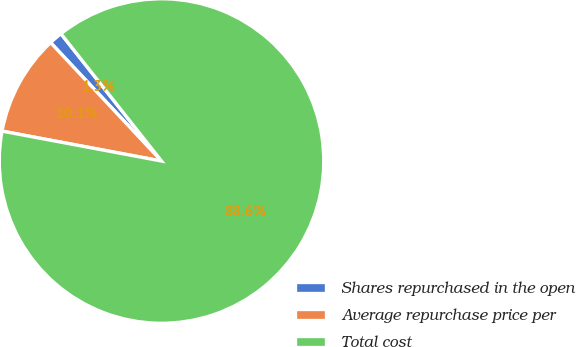Convert chart to OTSL. <chart><loc_0><loc_0><loc_500><loc_500><pie_chart><fcel>Shares repurchased in the open<fcel>Average repurchase price per<fcel>Total cost<nl><fcel>1.34%<fcel>10.07%<fcel>88.6%<nl></chart> 